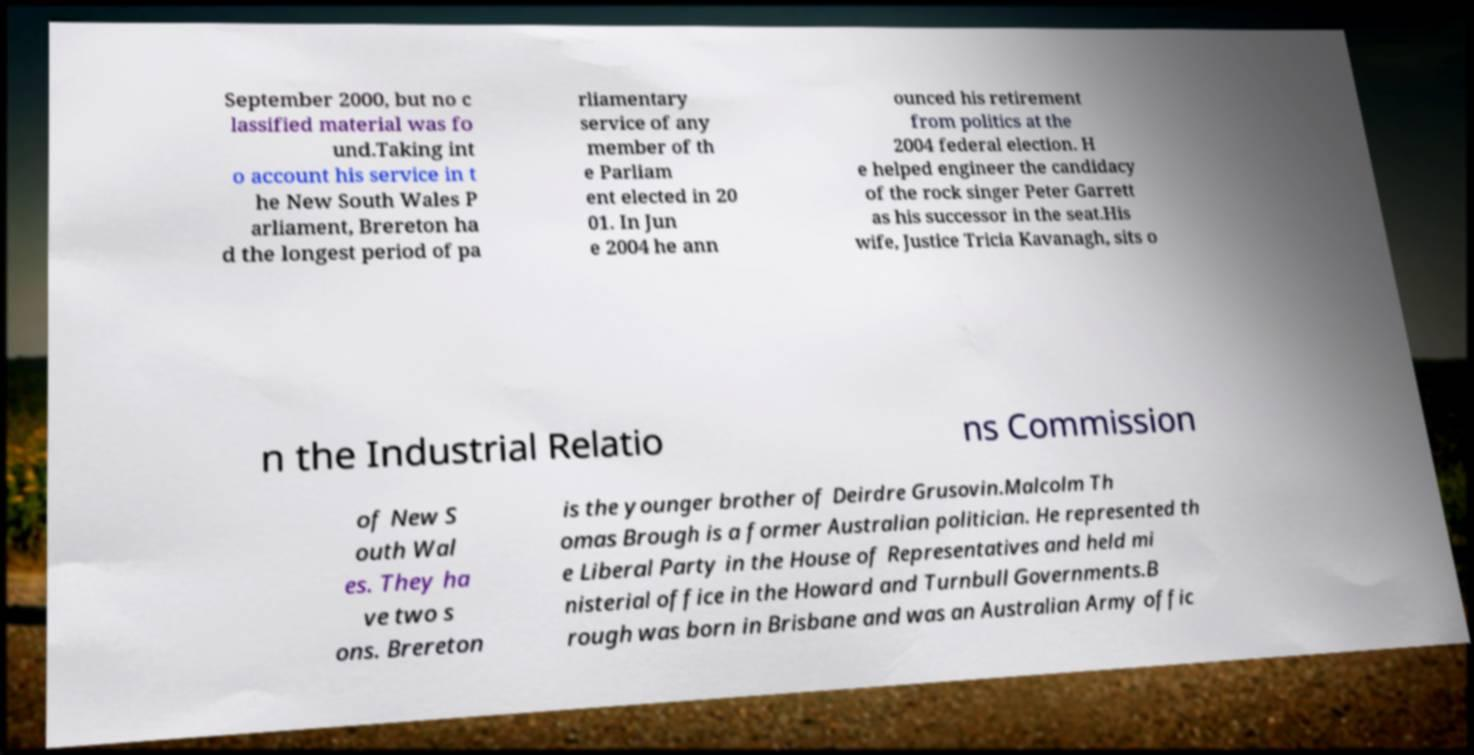I need the written content from this picture converted into text. Can you do that? September 2000, but no c lassified material was fo und.Taking int o account his service in t he New South Wales P arliament, Brereton ha d the longest period of pa rliamentary service of any member of th e Parliam ent elected in 20 01. In Jun e 2004 he ann ounced his retirement from politics at the 2004 federal election. H e helped engineer the candidacy of the rock singer Peter Garrett as his successor in the seat.His wife, Justice Tricia Kavanagh, sits o n the Industrial Relatio ns Commission of New S outh Wal es. They ha ve two s ons. Brereton is the younger brother of Deirdre Grusovin.Malcolm Th omas Brough is a former Australian politician. He represented th e Liberal Party in the House of Representatives and held mi nisterial office in the Howard and Turnbull Governments.B rough was born in Brisbane and was an Australian Army offic 